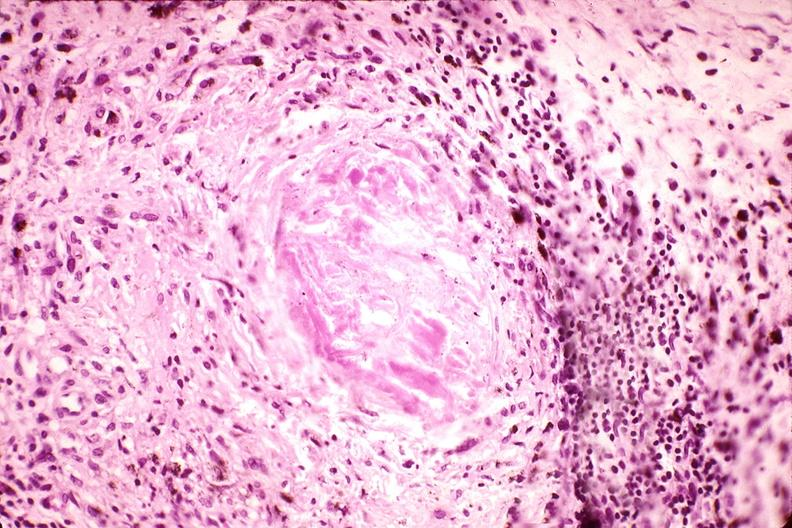what is present?
Answer the question using a single word or phrase. Musculoskeletal 